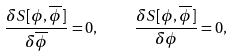Convert formula to latex. <formula><loc_0><loc_0><loc_500><loc_500>\frac { \delta S [ \phi , \overline { \phi } ] } { \delta \overline { \phi } } = 0 , \quad \frac { \delta S [ \phi , \overline { \phi } ] } { \delta \phi } = 0 ,</formula> 